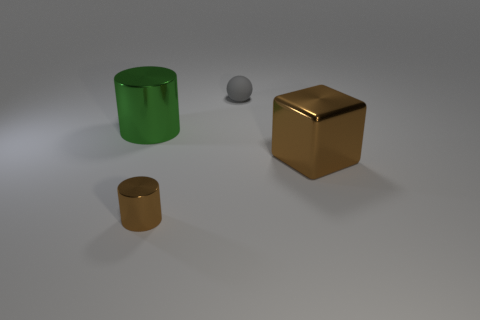Add 3 purple things. How many objects exist? 7 Subtract all cubes. How many objects are left? 3 Add 4 large shiny objects. How many large shiny objects exist? 6 Subtract 0 green cubes. How many objects are left? 4 Subtract all brown things. Subtract all large red metal spheres. How many objects are left? 2 Add 1 tiny cylinders. How many tiny cylinders are left? 2 